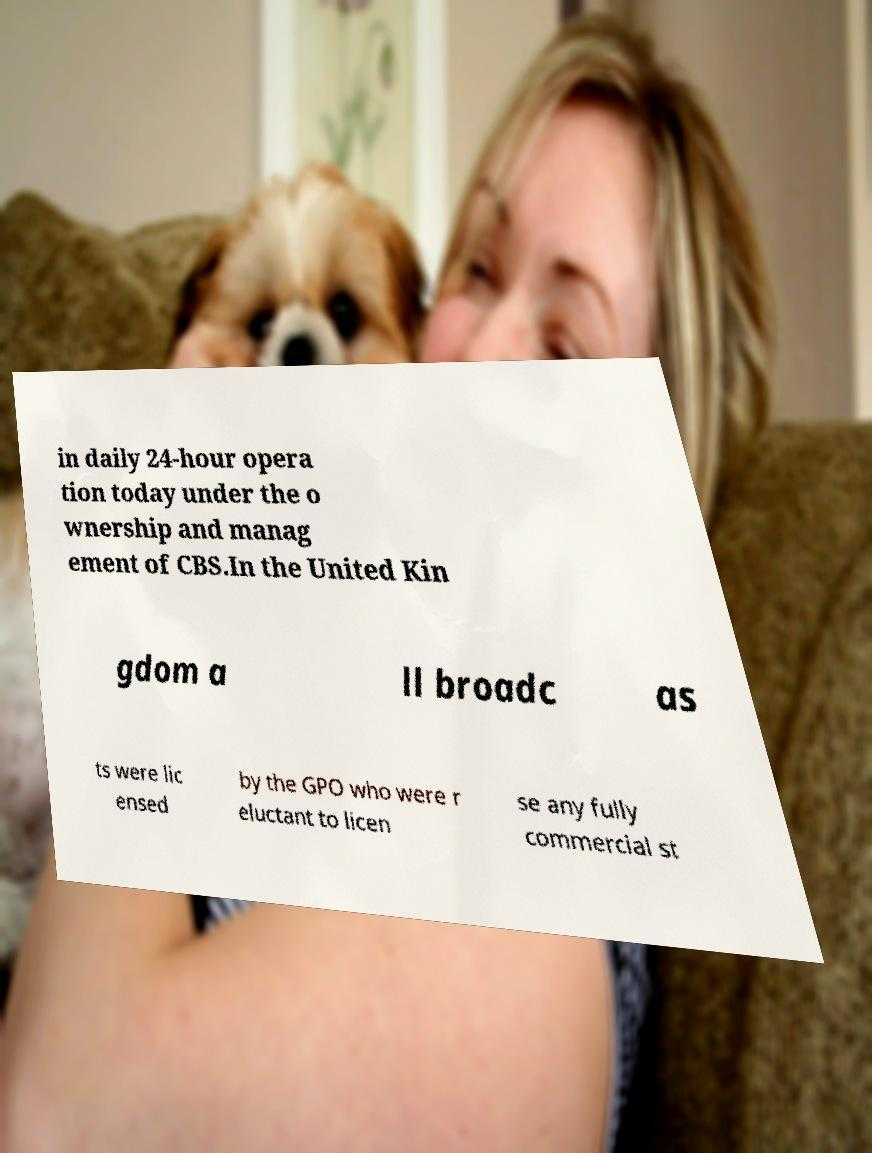Please identify and transcribe the text found in this image. in daily 24-hour opera tion today under the o wnership and manag ement of CBS.In the United Kin gdom a ll broadc as ts were lic ensed by the GPO who were r eluctant to licen se any fully commercial st 